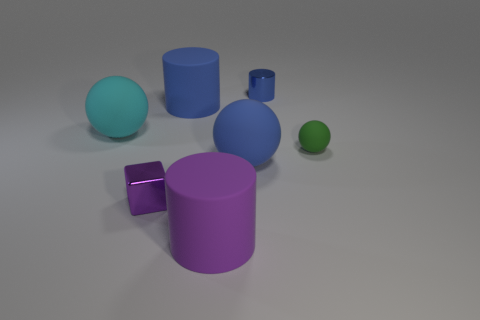Subtract all gray cylinders. Subtract all yellow spheres. How many cylinders are left? 3 Add 1 tiny cylinders. How many objects exist? 8 Subtract all cubes. How many objects are left? 6 Add 3 small metal cylinders. How many small metal cylinders are left? 4 Add 2 big blue balls. How many big blue balls exist? 3 Subtract 0 brown spheres. How many objects are left? 7 Subtract all small purple cylinders. Subtract all cyan matte things. How many objects are left? 6 